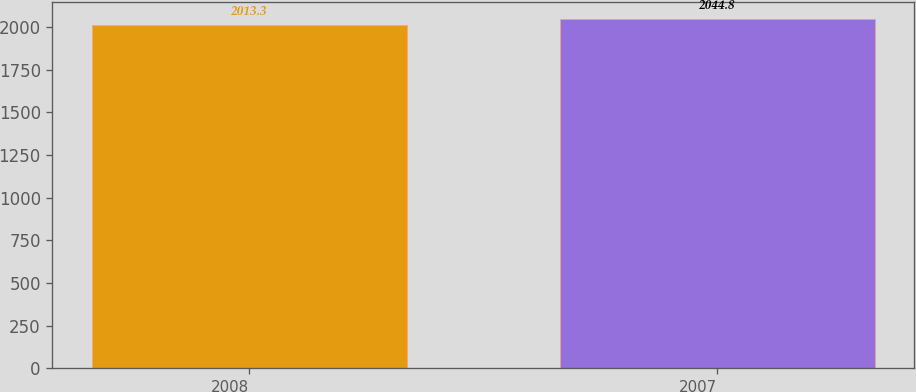Convert chart to OTSL. <chart><loc_0><loc_0><loc_500><loc_500><bar_chart><fcel>2008<fcel>2007<nl><fcel>2013.3<fcel>2044.8<nl></chart> 